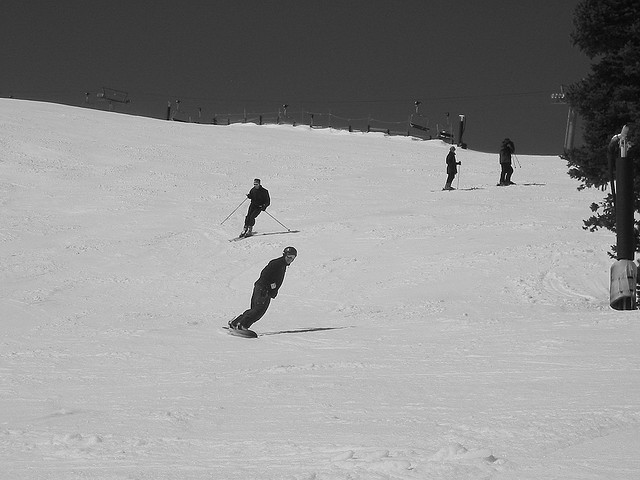<image>Are these people cross-country skiing? It's not clear if these people are cross-country skiing or not. The answer may depend on the specific scene. Are these people cross-country skiing? I am not sure if these people are cross-country skiing. It can be seen that some people are saying 'no' and some are saying 'yes'. 